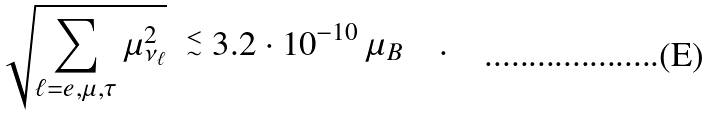Convert formula to latex. <formula><loc_0><loc_0><loc_500><loc_500>\sqrt { \sum _ { \ell = e , \mu , \tau } \mu _ { \nu _ { \ell } } ^ { 2 } } \ \stackrel { < } { _ { \sim } } 3 . 2 \cdot 1 0 ^ { - 1 0 } \, \mu _ { B } \quad .</formula> 